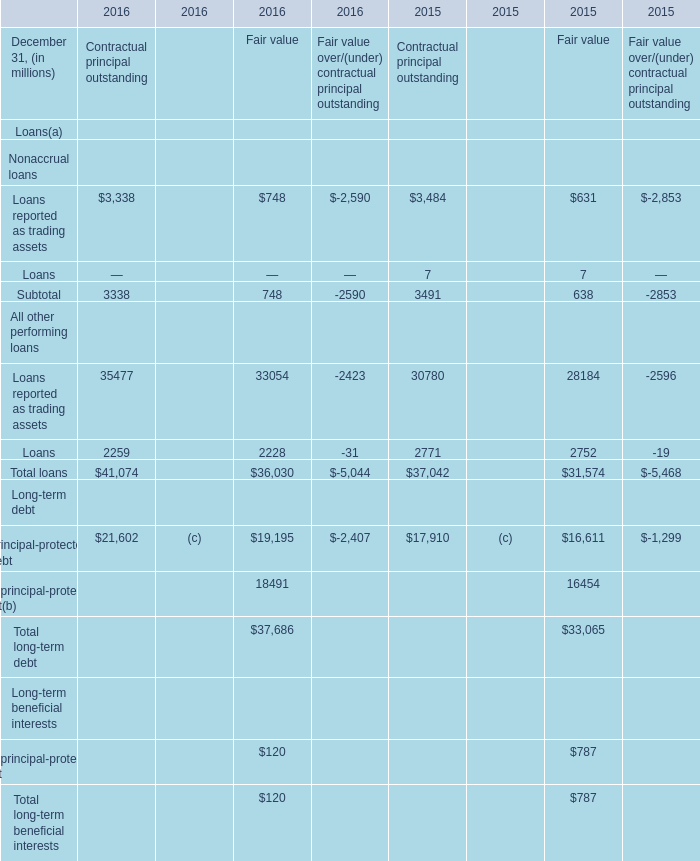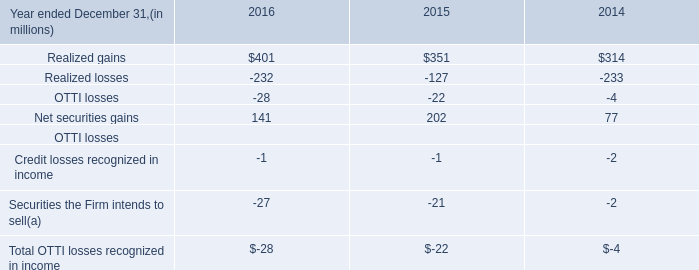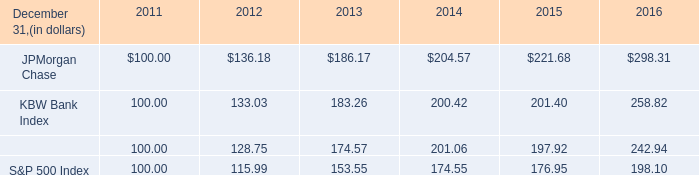What was the sum of Contractual principal outstanding without those Contractual principal outstanding greater than 4000, in 2016? (in million) 
Computations: (3338 + 2259)
Answer: 5597.0. 